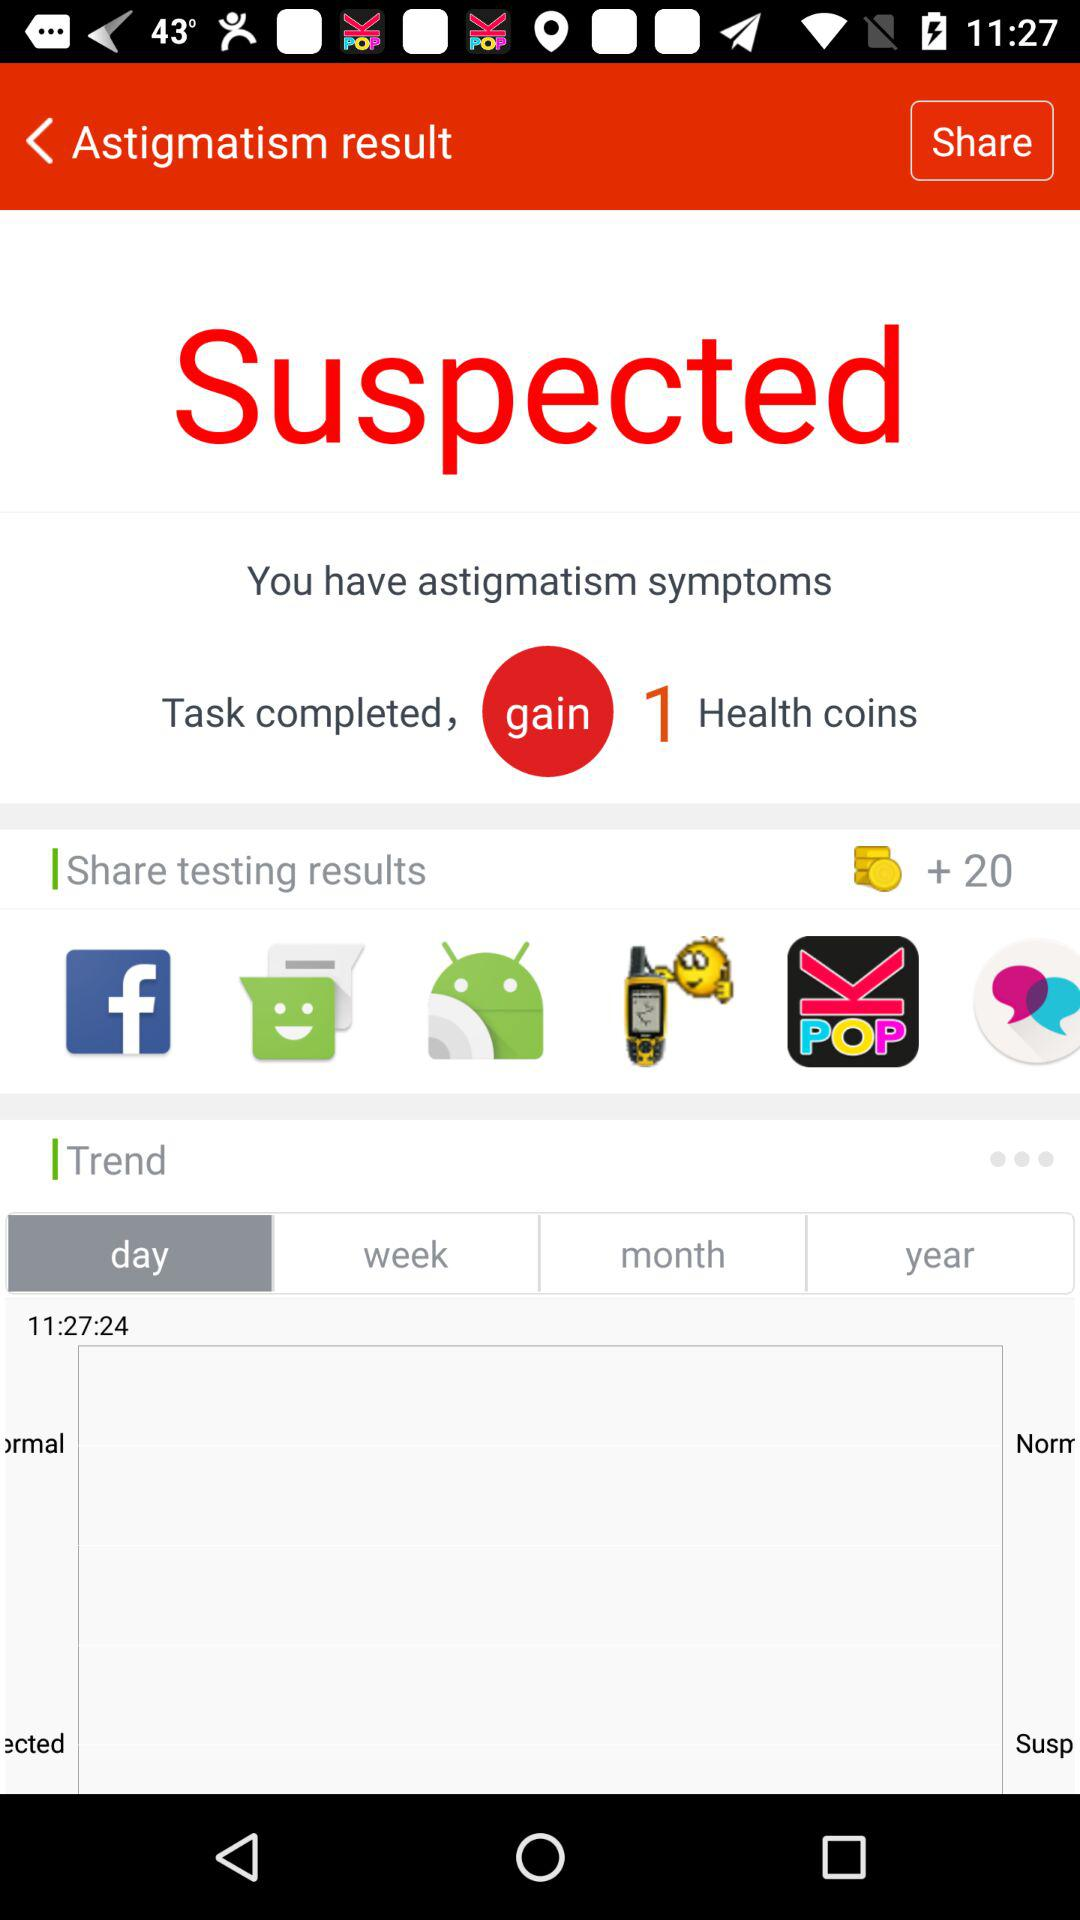How many coins in total are there? There are 20 coins in total. 